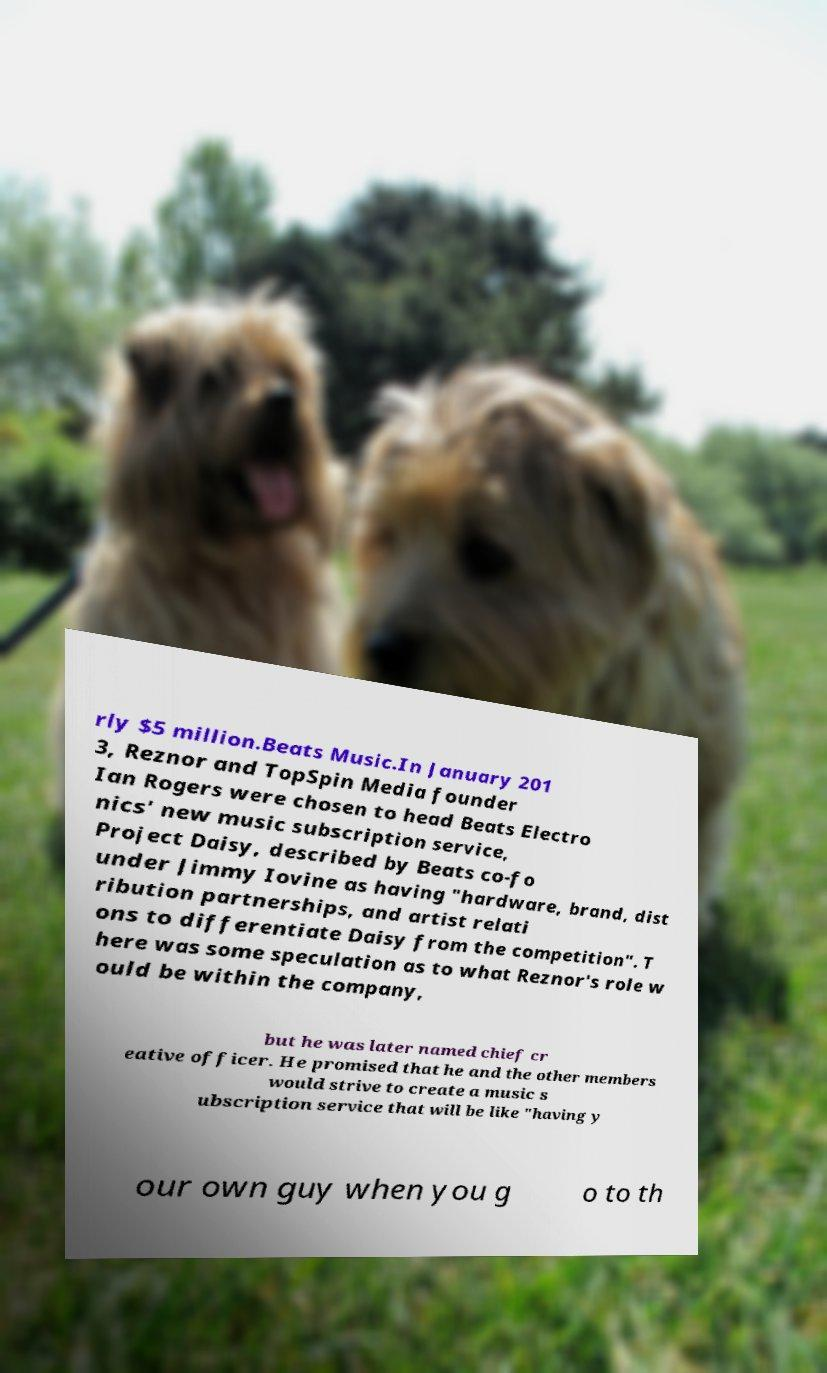Can you accurately transcribe the text from the provided image for me? rly $5 million.Beats Music.In January 201 3, Reznor and TopSpin Media founder Ian Rogers were chosen to head Beats Electro nics' new music subscription service, Project Daisy, described by Beats co-fo under Jimmy Iovine as having "hardware, brand, dist ribution partnerships, and artist relati ons to differentiate Daisy from the competition". T here was some speculation as to what Reznor's role w ould be within the company, but he was later named chief cr eative officer. He promised that he and the other members would strive to create a music s ubscription service that will be like "having y our own guy when you g o to th 